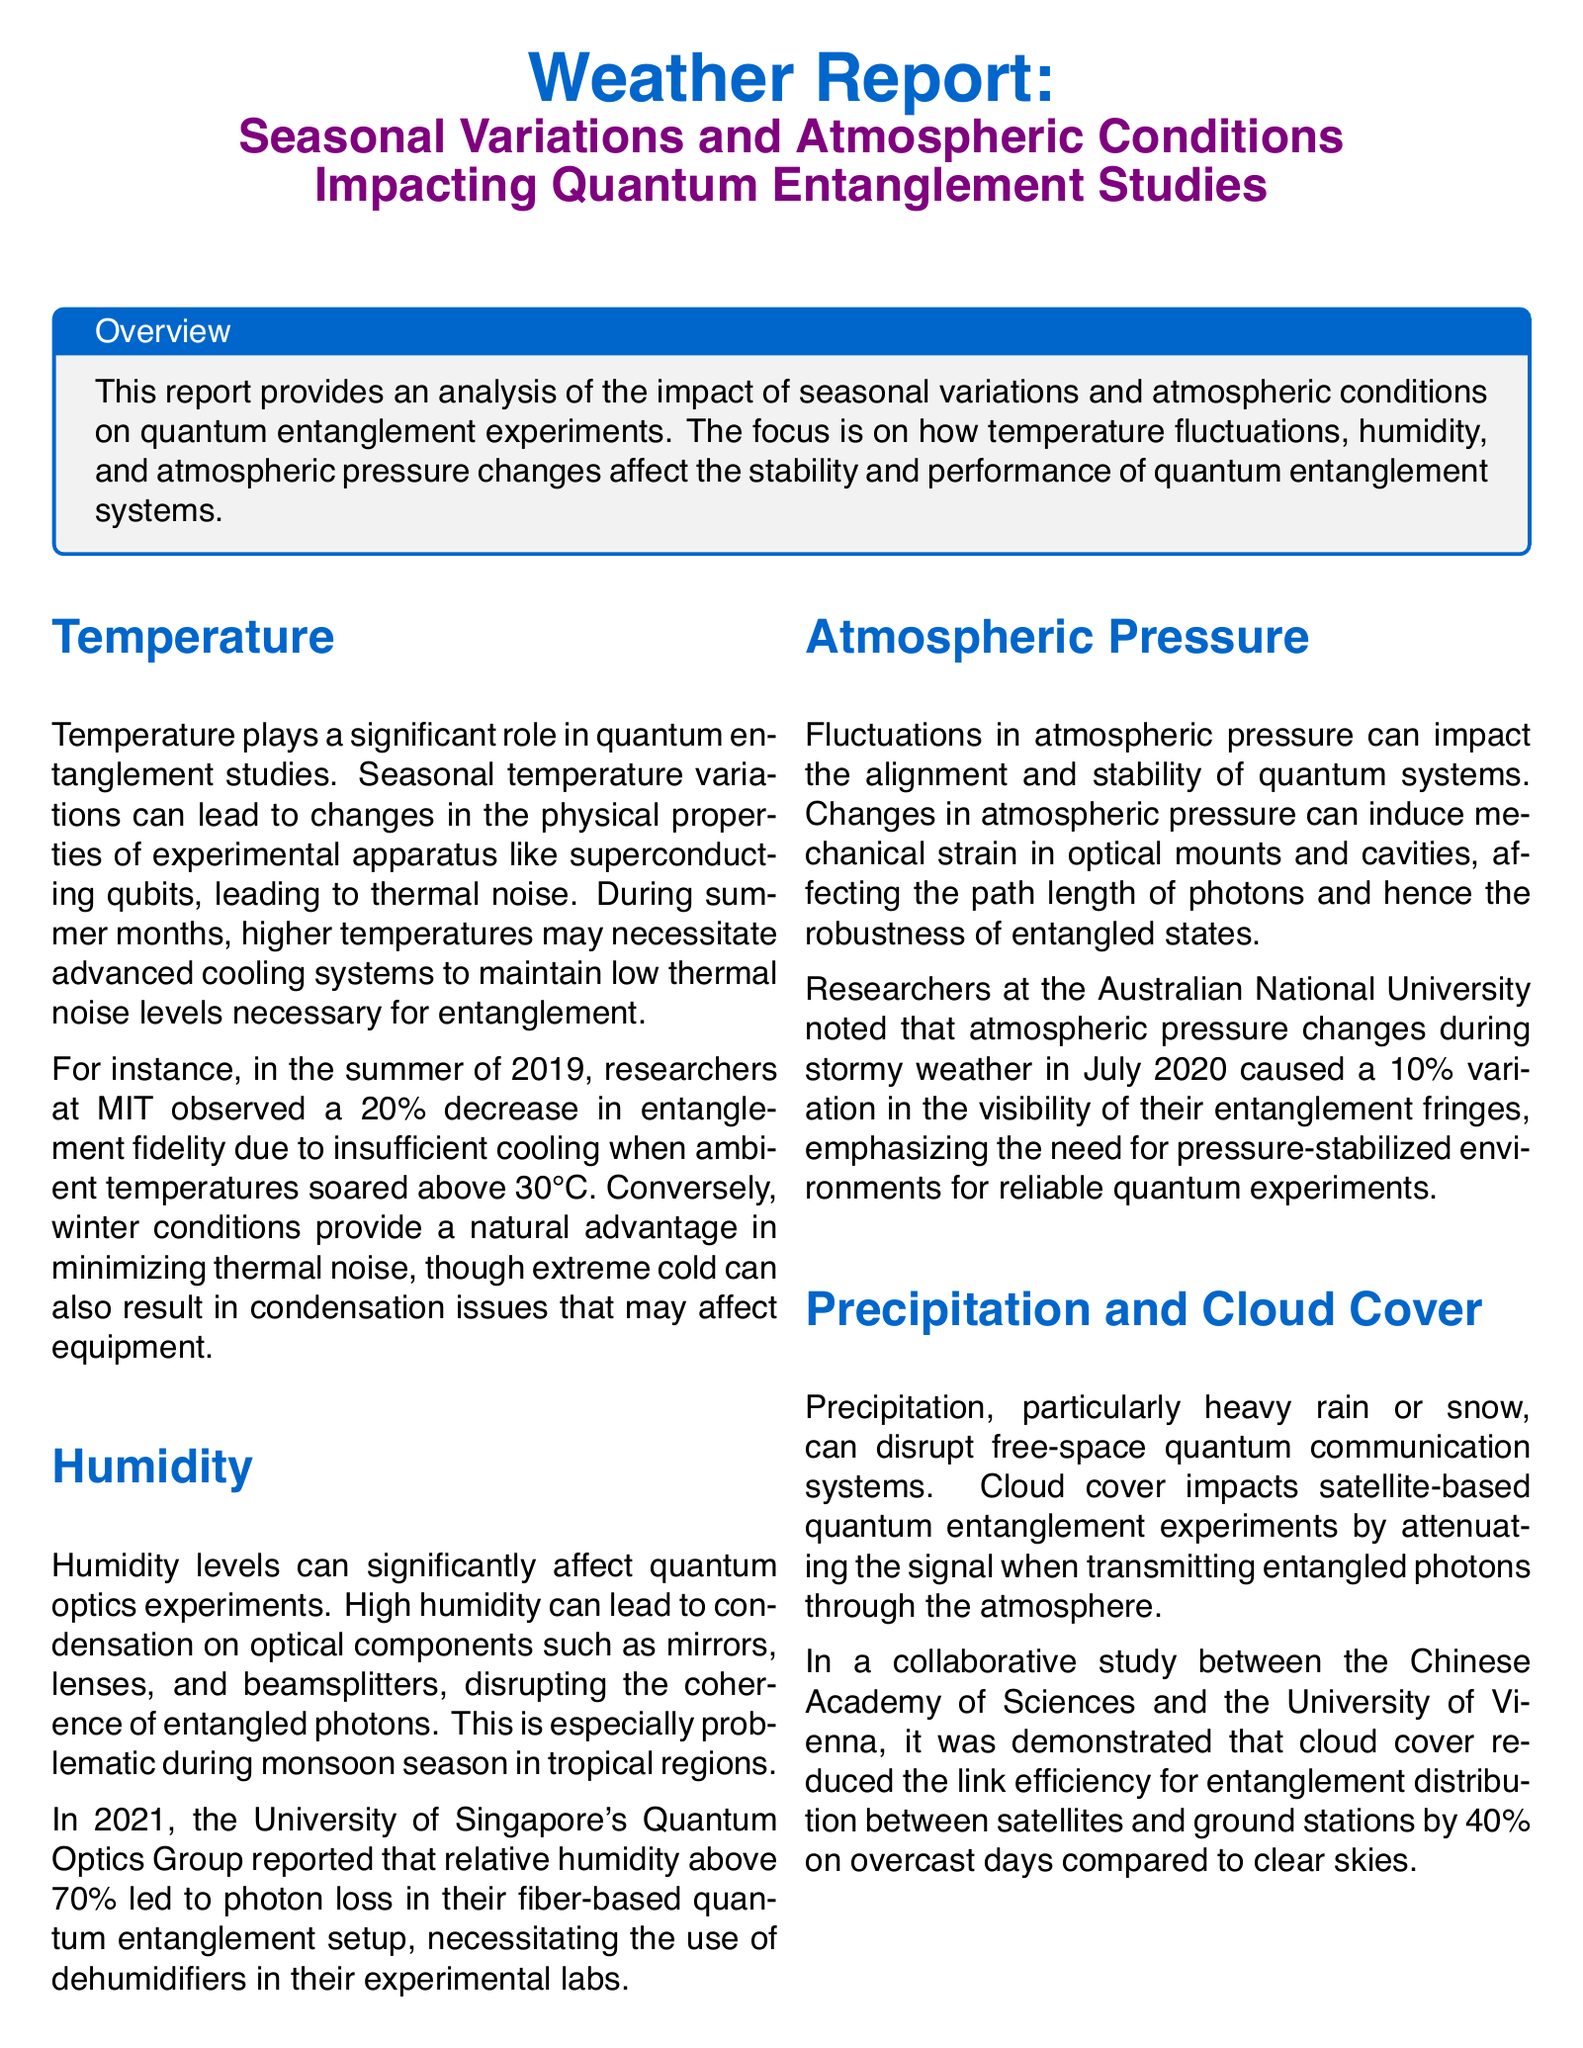What is the primary focus of the report? The report provides an analysis of the impact of seasonal variations and atmospheric conditions on quantum entanglement experiments.
Answer: Impact of seasonal variations and atmospheric conditions During which season was a 20% decrease in entanglement fidelity observed? In the summer of 2019, researchers at MIT observed a 20% decrease in entanglement fidelity.
Answer: Summer What humidity percentage led to photon loss in the 2021 report? The University of Singapore's Quantum Optics Group reported that relative humidity above 70% led to photon loss.
Answer: 70% What effect does heavy precipitation have on free-space quantum communication systems? Precipitation, particularly heavy rain or snow, can disrupt free-space quantum communication systems.
Answer: Disrupt How much did cloud cover reduce the link efficiency for entanglement distribution? Cloud cover reduced the link efficiency for entanglement distribution between satellites and ground stations by 40%.
Answer: 40% What atmospheric condition can cause mechanical strain in quantum systems? Fluctuations in atmospheric pressure can impact the alignment and stability of quantum systems.
Answer: Atmospheric pressure Which institution is mentioned in connection with atmospheric pressure changes affecting entanglement fringes? Researchers at the Australian National University noted that atmospheric pressure changes during stormy weather affected entanglement fringes.
Answer: Australian National University What is crucial for the advancement of quantum entanglement studies according to the conclusion? Understanding and mitigating the effects of seasonal variations and atmospheric conditions is crucial for the advancement of quantum entanglement studies.
Answer: Understanding and mitigating effects 